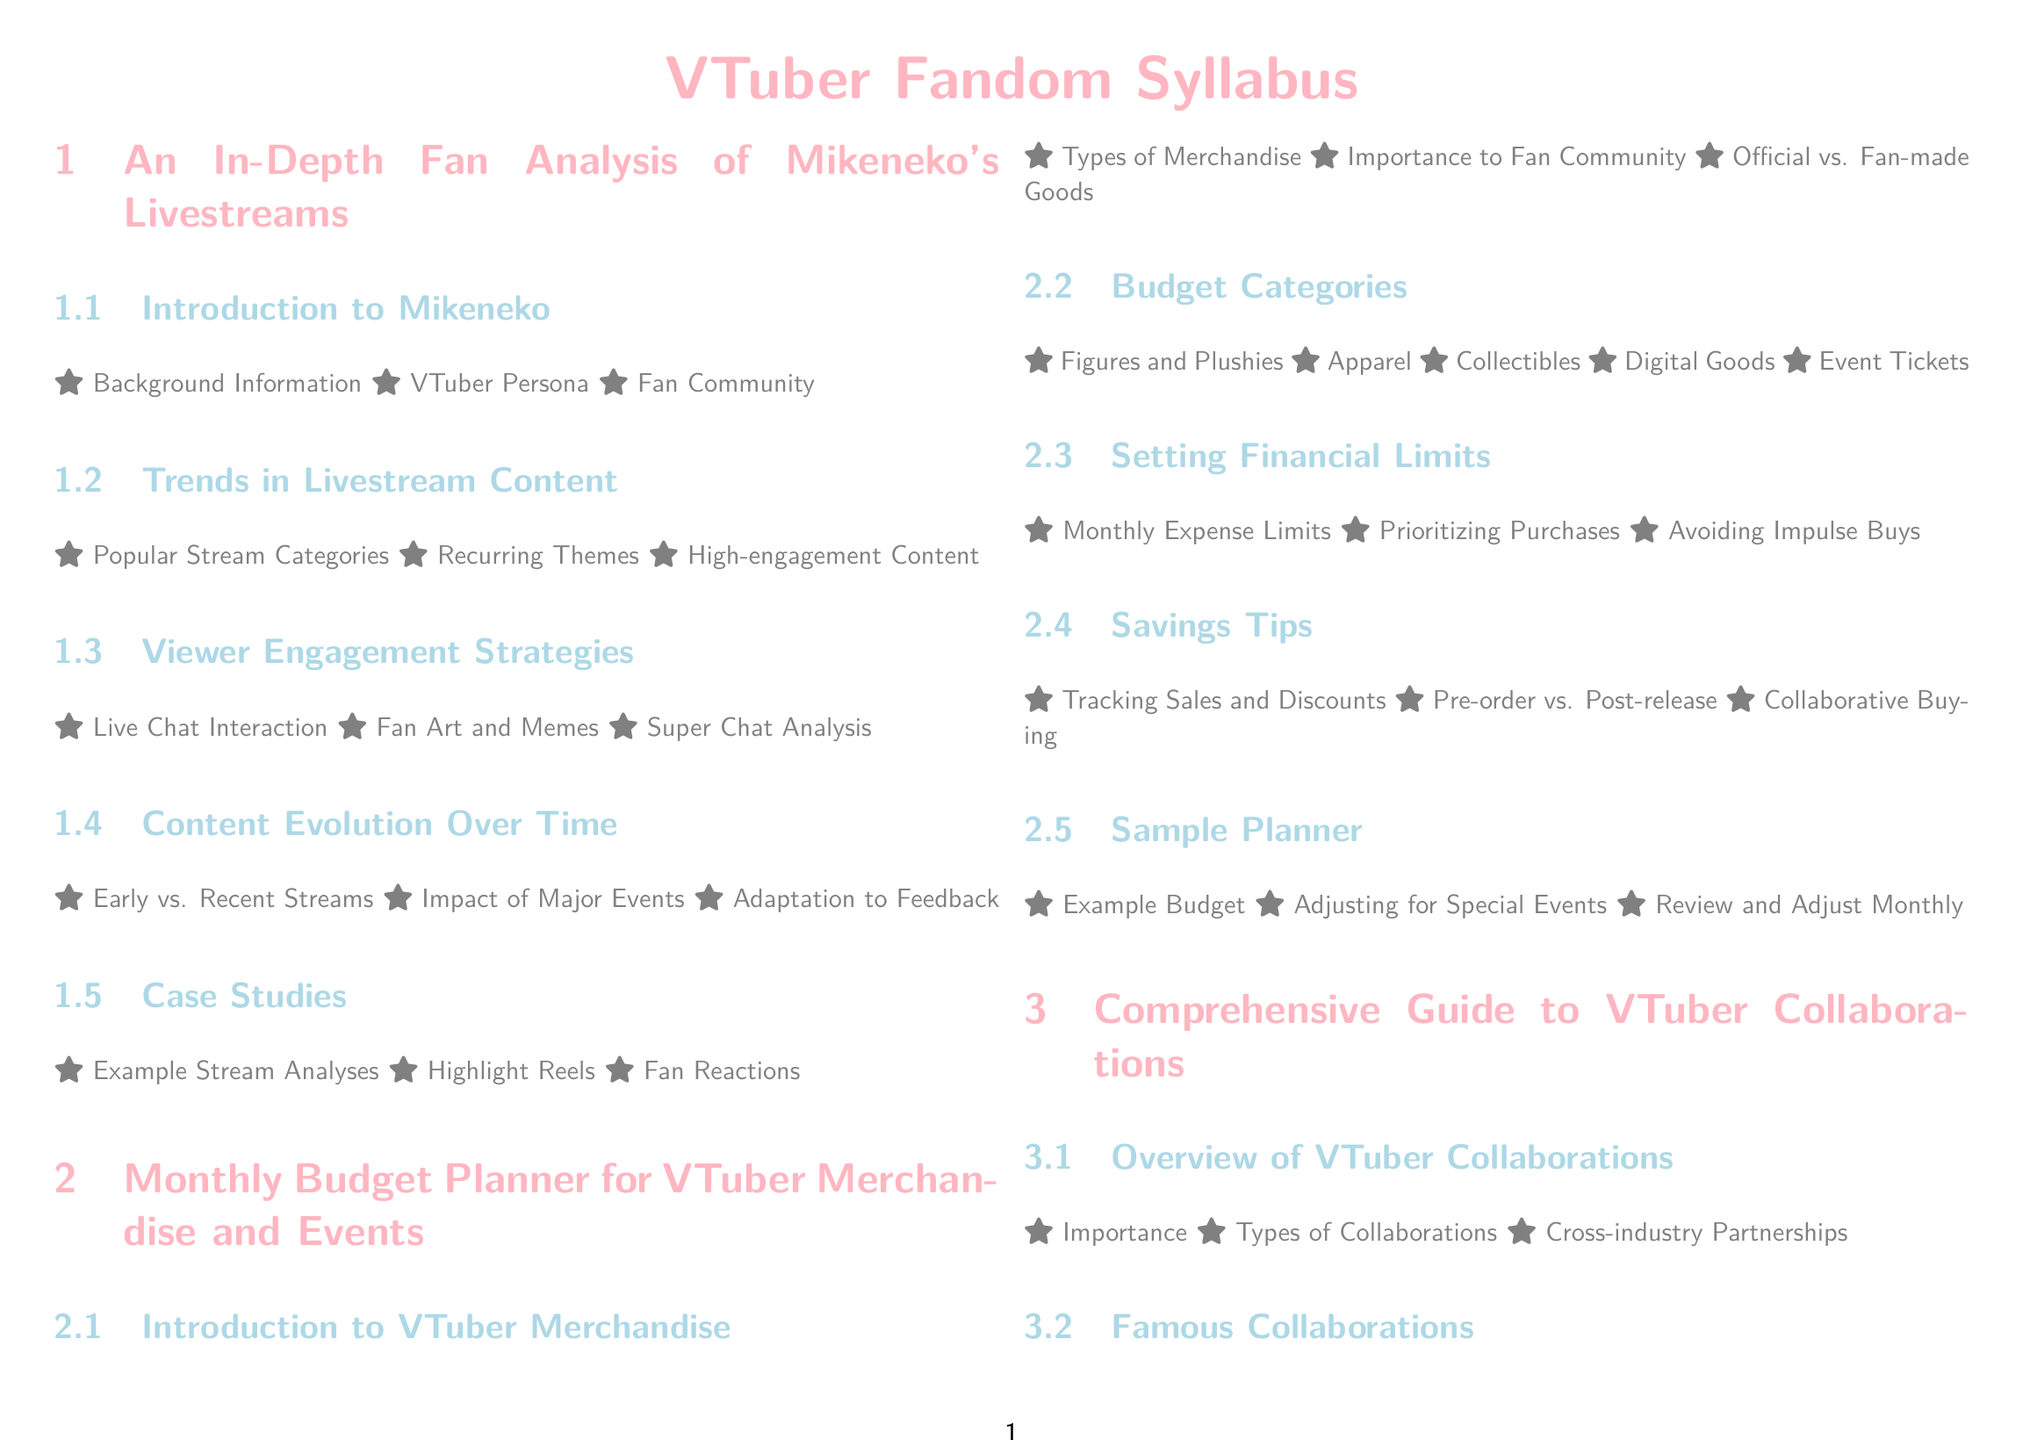what is the first section of the syllabus? The first section listed in the syllabus is about Mikeneko's livestreams.
Answer: An In-Depth Fan Analysis of Mikeneko's Livestreams what is one category of expenses in the monthly budget planner? The categories listed in the budget planner include various types of merchandise such as figures and apparel.
Answer: Figures and Plushies which VTuber agency is mentioned under famous collaborations? The syllabus lists notable collaborations, including those with various VTuber agencies.
Answer: Hololive Collaborations what is a major theme covered in viewer engagement strategies? The viewer engagement strategies examine several aspects of interaction with the fanbase, including the specifics of fan engagement.
Answer: Live Chat Interaction how many case studies are included in the comprehensive guide to VTuber collaborations? The section on collaborations contains specific examples to highlight key lessons learned from various partnerships.
Answer: Three which section discusses the demographic aspects of the VTuber community? The demographics are addressed under the section dedicated to the overall growth of the VTuber community.
Answer: VTuber Demographics what is a tip mentioned for saving money on VTuber merchandise? The syllabus provides practical suggestions for managing finances effectively while collecting merchandise.
Answer: Tracking Sales and Discounts what year did Mikeneko have her first streams? The historical overview gives information about the early timeline of Mikeneko's career, including her beginnings.
Answer: Early Career what interaction pattern does the study on VTuber community growth examine? The interaction patterns look into how fans engage within the community and contribute creatively.
Answer: Fan Art and Memes 